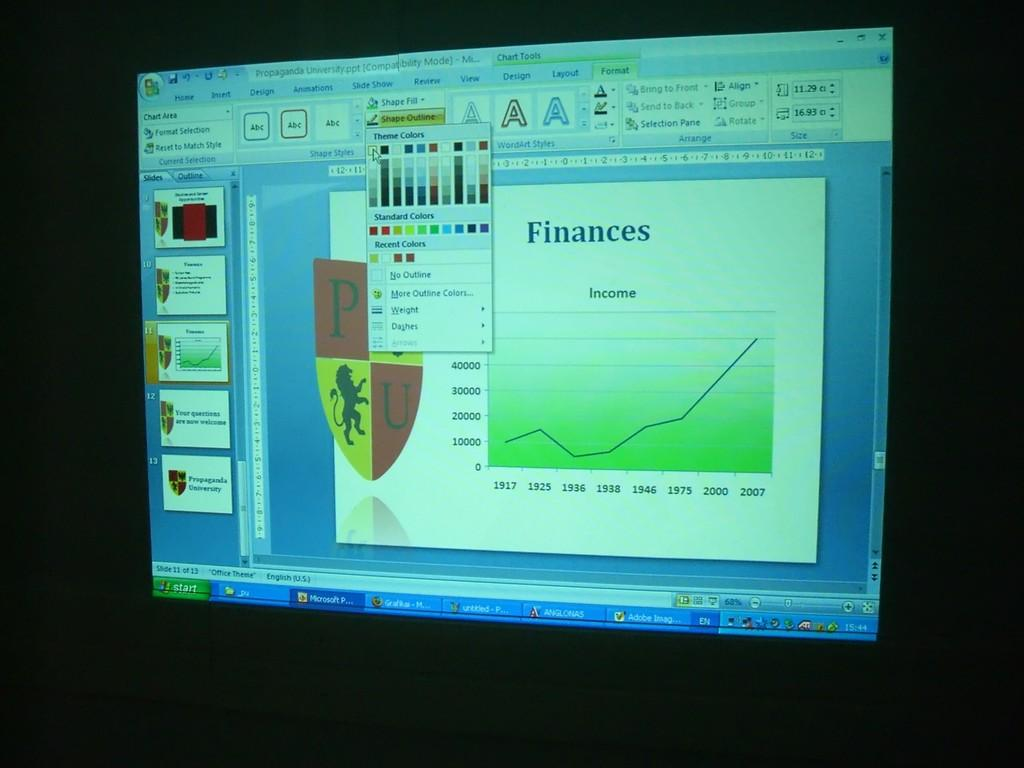Provide a one-sentence caption for the provided image. A screen with finances written on it and a chart. 